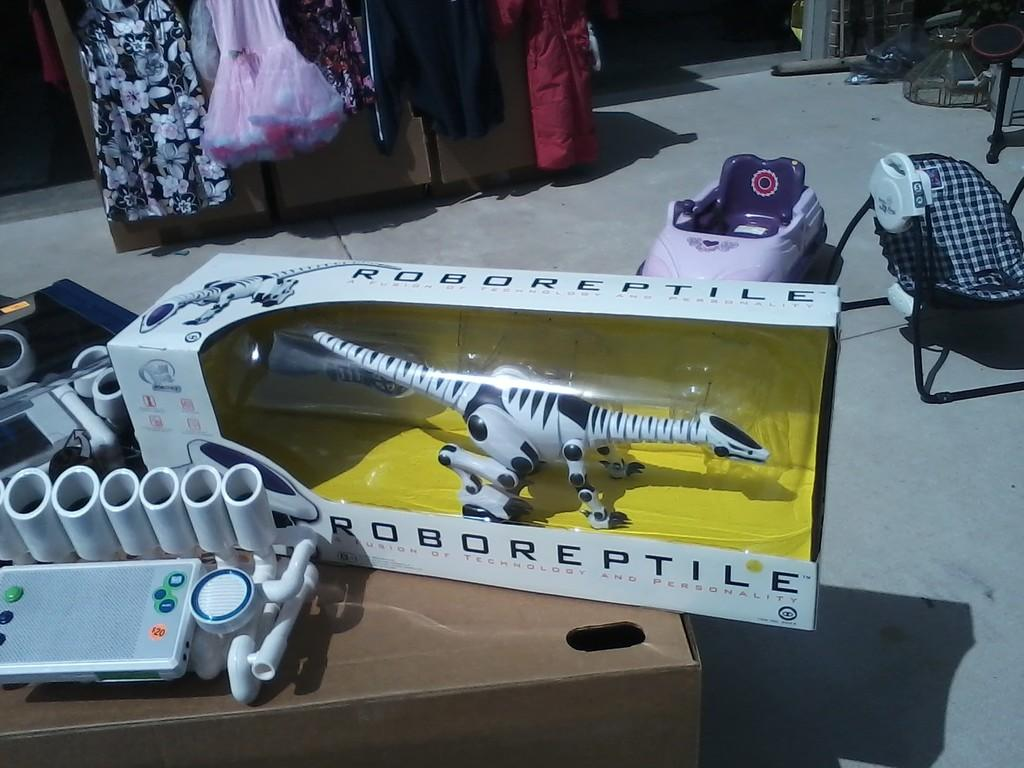<image>
Create a compact narrative representing the image presented. A toy called Robo Reptile that is still in it's box 